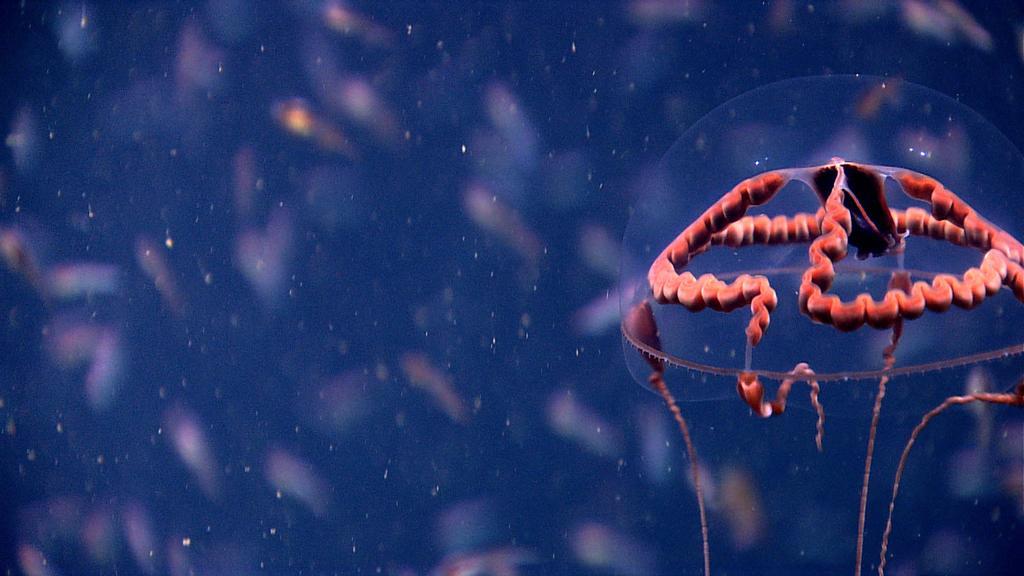How would you summarize this image in a sentence or two? In this image we can see a jellyfish. The background of the image is blur. 